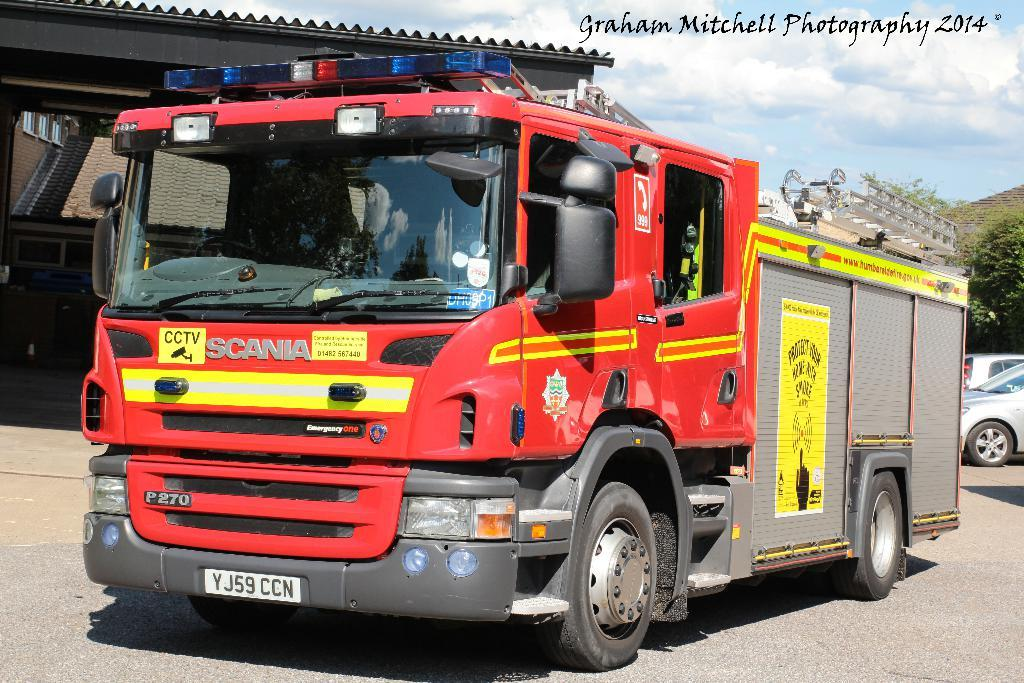What can be seen on the road in the image? There are vehicles on the road in the image. What else is present in the image besides the vehicles? There is a poster, a shelter, trees, and the sky with clouds visible in the background of the image. What type of cent is depicted on the poster in the image? There is no cent present on the poster or in the image. 